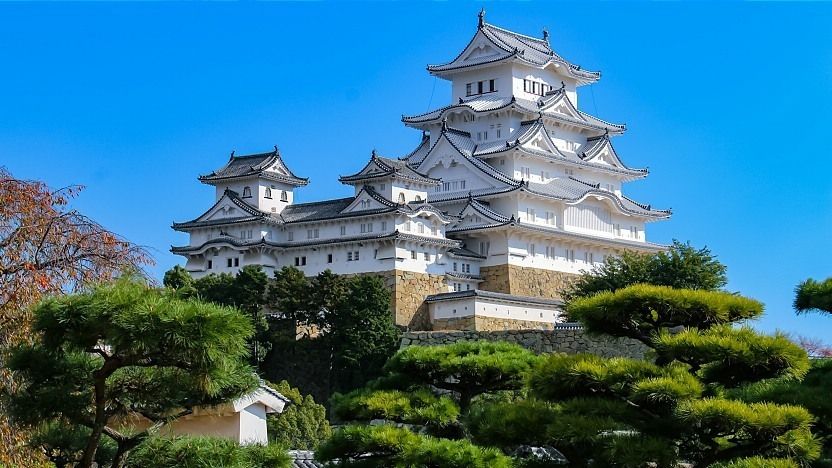Analyze the image in a comprehensive and detailed manner. The image beautifully captures Himeji Castle, an iconic landmark of Japan. The castle's grand white structure majestically stands tall, with multiple tiers and roofs adding to its imposing and elegant presence. Each layer of the castle showcases intricate architectural details, reflecting traditional Japanese design. The castle is perched on a gently sloping hill, surrounded by a lush sea of trees exhibiting vibrant green and rich autumn hues, creating a striking contrast against the pristine white facade. The clear blue sky above provides a serene and tranquil backdrop, enhancing the overall visual appeal. The image is taken from a low angle, emphasizing the castle's towering stature and the careful detail in its construction. This perspective also reveals the strategic positioning of the castle, designed to overlook the surrounding landscape. The photograph is a testament to the castle's historical and cultural significance, as well as its architectural grandeur. 